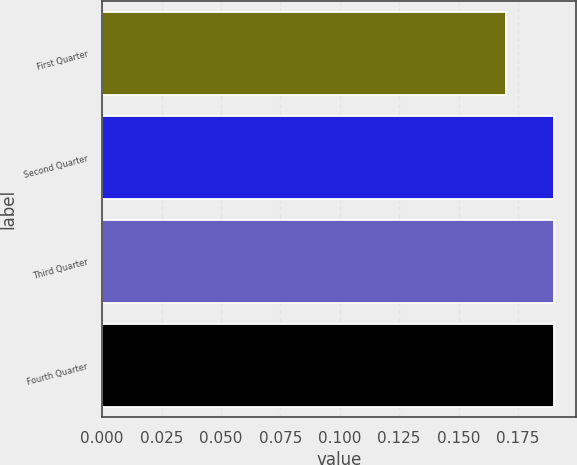<chart> <loc_0><loc_0><loc_500><loc_500><bar_chart><fcel>First Quarter<fcel>Second Quarter<fcel>Third Quarter<fcel>Fourth Quarter<nl><fcel>0.17<fcel>0.19<fcel>0.19<fcel>0.19<nl></chart> 